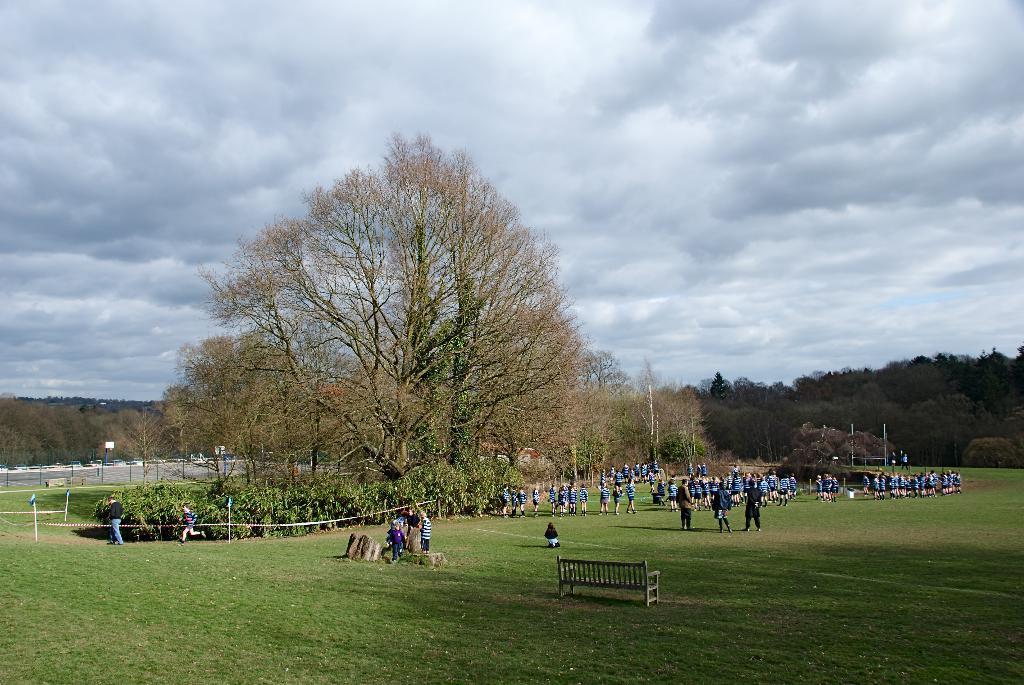Could you give a brief overview of what you see in this image? In the image there is a garden and there are a lot of people standing in the garden, there is a huge tree on the left side and around that there are small plants and in the background there are many other trees. 